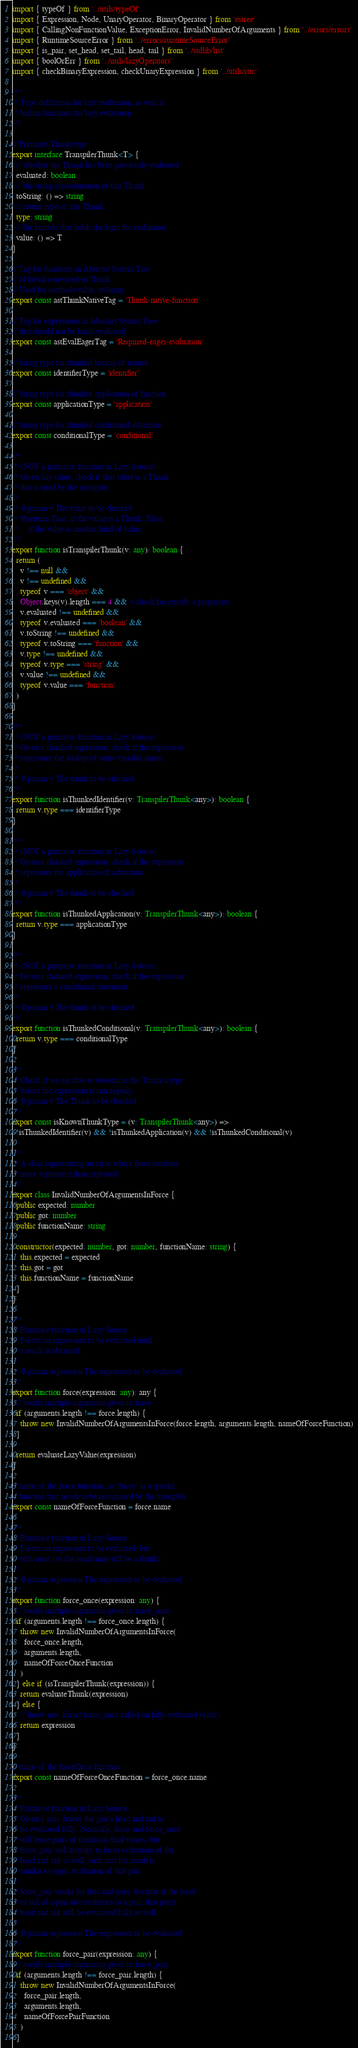<code> <loc_0><loc_0><loc_500><loc_500><_TypeScript_>import { typeOf } from '../utils/typeOf'
import { Expression, Node, UnaryOperator, BinaryOperator } from 'estree'
import { CallingNonFunctionValue, ExceptionError, InvalidNumberOfArguments } from '../errors/errors'
import { RuntimeSourceError } from '../errors/runtimeSourceError'
import { is_pair, set_head, set_tail, head, tail } from '../stdlib/list'
import { boolOrErr } from '../utils/lazyOperators'
import { checkBinaryExpression, checkUnaryExpression } from '../utils/rttc'

/**
 * Type definitions for lazy evaluation, as well as
 * builtin functions for lazy evaluation
 */

// Primitive Thunk type
export interface TranspilerThunk<T> {
  // whether the Thunk has been previously evaluated
  evaluated: boolean
  // the string representation of this Thunk
  toString: () => string
  // return type of this Thunk
  type: string
  // the lambda that holds the logic for evaluation
  value: () => T
}

// Tag for functions in Abstract Syntax Tree
// of literal converted to Thunk.
// Used for methods value, toString.
export const astThunkNativeTag = 'Thunk-native-function'

// Tag for expressions in Abstract Syntax Tree
// that should not be lazily evaluated.
export const astEvalEagerTag = 'Required-eager-evaluation'

// String type for thunked lookup of names
export const identifierType = 'identifier'

// String type for thunked application of function
export const applicationType = 'application'

// String type for thunked conditional statement
export const conditionalType = 'conditional'

/**
 * (NOT a primitive function in Lazy Source)
 * Given any value, check if that value is a Thunk
 * that is used by the transpiler.
 *
 * @param v The value to be checked.
 * @returns True, if the value is a Thunk. False,
 *     if the value is another kind of value.
 */
export function isTranspilerThunk(v: any): boolean {
  return (
    v !== null &&
    v !== undefined &&
    typeof v === 'object' &&
    Object.keys(v).length === 4 && // check for exactly 4 properties
    v.evaluated !== undefined &&
    typeof v.evaluated === 'boolean' &&
    v.toString !== undefined &&
    typeof v.toString === 'function' &&
    v.type !== undefined &&
    typeof v.type === 'string' &&
    v.value !== undefined &&
    typeof v.value === 'function'
  )
}

/**
 * (NOT a primitive function in Lazy Source)
 * Given a thunked expression, check if the expression
 * represents the lookup of some variable name.
 *
 * @param v The thunk to be checked.
 */
export function isThunkedIdentifier(v: TranspilerThunk<any>): boolean {
  return v.type === identifierType
}

/**
 * (NOT a primitive function in Lazy Source)
 * Given a thunked expression, check if the expression
 * represents the application of a function.
 *
 * @param v The thunk to be checked.
 */
export function isThunkedApplication(v: TranspilerThunk<any>): boolean {
  return v.type === applicationType
}

/**
 * (NOT a primitive function in Lazy Source)
 * Given a thunked expression, check if the expression
 * represents a conditional statement.
 *
 * @param v The thunk to be checked.
 */
export function isThunkedConditional(v: TranspilerThunk<any>): boolean {
  return v.type === conditionalType
}

/**
 * Check if we are able to determine the Thunk's type
 * before the expression is run eagerly.
 * @param v The Thunk to be checked.
 */
export const isKnownThunkType = (v: TranspilerThunk<any>) =>
  !isThunkedIdentifier(v) && !isThunkedApplication(v) && !isThunkedConditional(v)

/**
 * A class representing an error where force receives
 * more arguments than expected.
 */
export class InvalidNumberOfArgumentsInForce {
  public expected: number
  public got: number
  public functionName: string

  constructor(expected: number, got: number, functionName: string) {
    this.expected = expected
    this.got = got
    this.functionName = functionName
  }
}

/**
 * Primitive function in Lazy Source.
 * Forces an expression to be evaluated until
 * a result is obtained.
 *
 * @param expression The expression to be evaluated.
 */
export function force(expression: any): any {
  // avoids multiple arguments given to force
  if (arguments.length !== force.length) {
    throw new InvalidNumberOfArgumentsInForce(force.length, arguments.length, nameOfForceFunction)
  }

  return evaluateLazyValue(expression)
}

// name of the force function, as "force" is a special
// function that needs to be recognised by the transpiler
export const nameOfForceFunction = force.name

/**
 * Primitive function in Lazy Source.
 * Forces an expression to be evaluated, but
 * only once (so the result may still be a thunk).
 *
 * @param expression The expression to be evaluated.
 */
export function force_once(expression: any) {
  // avoids multiple arguments given to force_once
  if (arguments.length !== force_once.length) {
    throw new InvalidNumberOfArgumentsInForce(
      force_once.length,
      arguments.length,
      nameOfForceOnceFunction
    )
  } else if (isTranspilerThunk(expression)) {
    return evaluateThunk(expression)
  } else {
    // throw new Error('force_once called on fully evaluated value')
    return expression
  }
}

// name of the forceOnce function
export const nameOfForceOnceFunction = force_once.name

/**
 * Primitive function in Lazy Source.
 * Given a pair, forces the pair's head and tail to
 * be evaluated fully. Normally, force and force_once
 * will leave pairs of thunks as final values, but
 * force_pair will attempt to force evaluation of the
 * head and tail as well, such that the result is
 * similar to eager evaluation of that pair.
 *
 * force_pair works for lists and trees, because if the head
 * or tail of a pair also evaluates to a pair, that pair's
 * head and tail will be evaluated fully as well.
 *
 * @param expression The expression to be evaluated.
 */
export function force_pair(expression: any) {
  // avoids multiple arguments given to force_pair
  if (arguments.length !== force_pair.length) {
    throw new InvalidNumberOfArgumentsInForce(
      force_pair.length,
      arguments.length,
      nameOfForcePairFunction
    )
  }</code> 